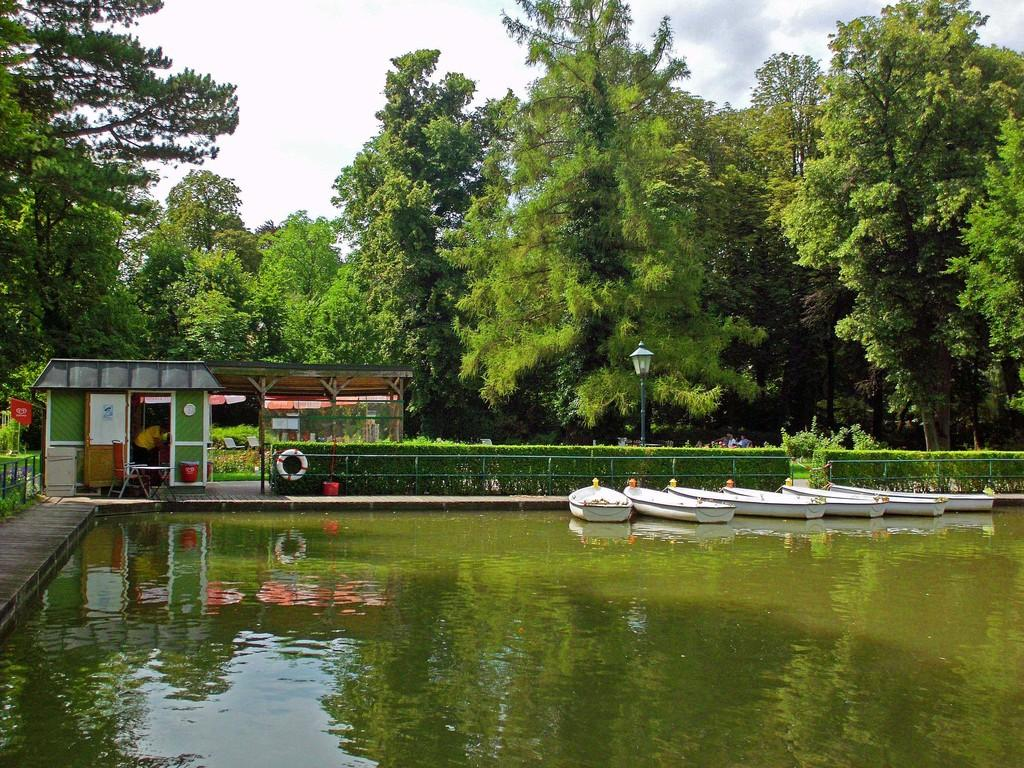What can be seen floating on the water in the image? There are boats on the water in the image. What type of barrier is present in the image? There is a fence in the image. What type of vegetation is visible in the image? There are plants in the image. What is attached to the fence in the image? A swimming ring is on the fence. What is located on a raised surface in the image? There are objects on a platform in the image. Where is the person in the image located? The person is in a room in the image. What feature allows access to the room in the image? There is a door in the image. What type of natural scenery is visible in the image? Trees are visible in the image. What part of the sky is visible in the image? The sky is visible in the image. What time of day is it in the image, and what is the person doing in the morning? The time of day is not specified in the image, and there is no indication of what the person might be doing in the morning. How much does it cost to make a copy of the image? The cost of making a copy of the image is not relevant to the content of the image itself. 